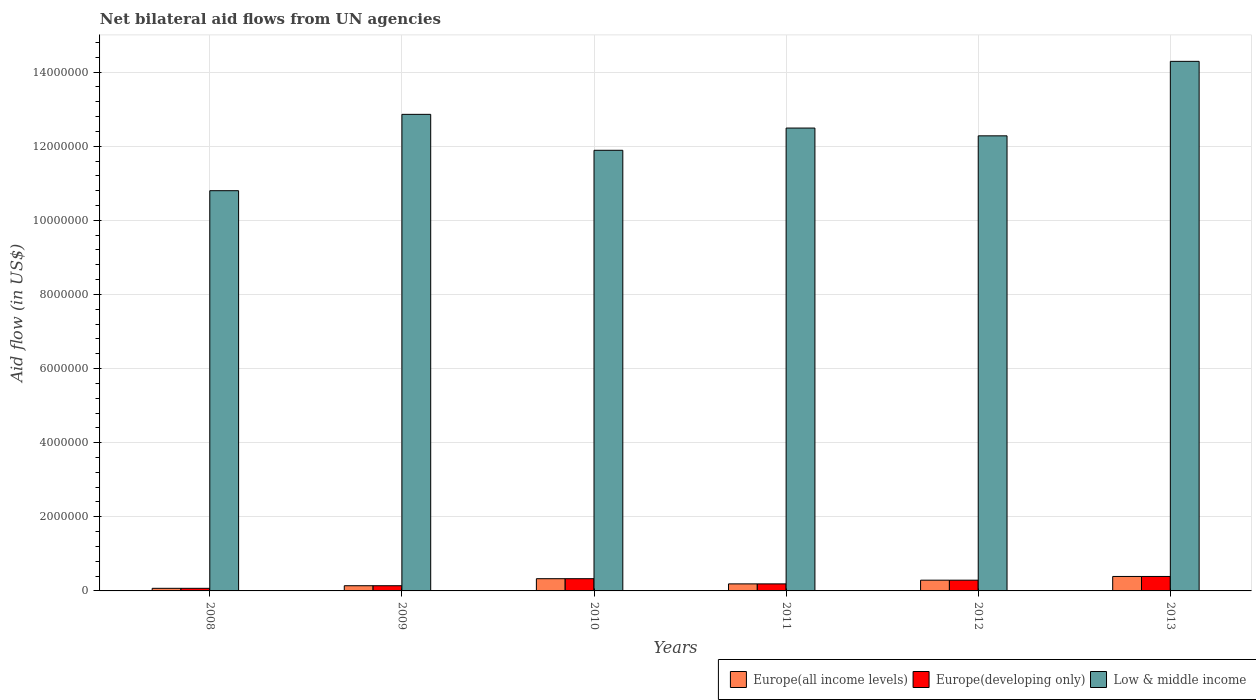How many groups of bars are there?
Make the answer very short. 6. Are the number of bars per tick equal to the number of legend labels?
Ensure brevity in your answer.  Yes. Are the number of bars on each tick of the X-axis equal?
Ensure brevity in your answer.  Yes. What is the net bilateral aid flow in Europe(developing only) in 2009?
Your response must be concise. 1.40e+05. Across all years, what is the maximum net bilateral aid flow in Low & middle income?
Your answer should be compact. 1.43e+07. Across all years, what is the minimum net bilateral aid flow in Europe(all income levels)?
Provide a succinct answer. 7.00e+04. In which year was the net bilateral aid flow in Low & middle income maximum?
Offer a very short reply. 2013. What is the total net bilateral aid flow in Low & middle income in the graph?
Ensure brevity in your answer.  7.46e+07. What is the difference between the net bilateral aid flow in Europe(all income levels) in 2010 and that in 2012?
Ensure brevity in your answer.  4.00e+04. What is the difference between the net bilateral aid flow in Low & middle income in 2010 and the net bilateral aid flow in Europe(all income levels) in 2012?
Your answer should be very brief. 1.16e+07. What is the average net bilateral aid flow in Europe(all income levels) per year?
Keep it short and to the point. 2.35e+05. In the year 2010, what is the difference between the net bilateral aid flow in Low & middle income and net bilateral aid flow in Europe(all income levels)?
Your response must be concise. 1.16e+07. What is the ratio of the net bilateral aid flow in Europe(developing only) in 2009 to that in 2013?
Provide a succinct answer. 0.36. Is the net bilateral aid flow in Europe(all income levels) in 2008 less than that in 2010?
Ensure brevity in your answer.  Yes. What is the difference between the highest and the second highest net bilateral aid flow in Europe(developing only)?
Your answer should be compact. 6.00e+04. What is the difference between the highest and the lowest net bilateral aid flow in Low & middle income?
Give a very brief answer. 3.49e+06. In how many years, is the net bilateral aid flow in Low & middle income greater than the average net bilateral aid flow in Low & middle income taken over all years?
Make the answer very short. 3. What does the 2nd bar from the left in 2011 represents?
Make the answer very short. Europe(developing only). What does the 3rd bar from the right in 2009 represents?
Provide a short and direct response. Europe(all income levels). Are all the bars in the graph horizontal?
Give a very brief answer. No. Does the graph contain any zero values?
Offer a terse response. No. Does the graph contain grids?
Give a very brief answer. Yes. How many legend labels are there?
Your answer should be very brief. 3. How are the legend labels stacked?
Offer a terse response. Horizontal. What is the title of the graph?
Make the answer very short. Net bilateral aid flows from UN agencies. Does "Togo" appear as one of the legend labels in the graph?
Provide a succinct answer. No. What is the label or title of the X-axis?
Ensure brevity in your answer.  Years. What is the label or title of the Y-axis?
Offer a very short reply. Aid flow (in US$). What is the Aid flow (in US$) of Europe(all income levels) in 2008?
Your response must be concise. 7.00e+04. What is the Aid flow (in US$) in Europe(developing only) in 2008?
Provide a succinct answer. 7.00e+04. What is the Aid flow (in US$) of Low & middle income in 2008?
Ensure brevity in your answer.  1.08e+07. What is the Aid flow (in US$) in Low & middle income in 2009?
Give a very brief answer. 1.29e+07. What is the Aid flow (in US$) in Europe(all income levels) in 2010?
Ensure brevity in your answer.  3.30e+05. What is the Aid flow (in US$) in Low & middle income in 2010?
Ensure brevity in your answer.  1.19e+07. What is the Aid flow (in US$) in Europe(all income levels) in 2011?
Your answer should be very brief. 1.90e+05. What is the Aid flow (in US$) in Europe(developing only) in 2011?
Your answer should be very brief. 1.90e+05. What is the Aid flow (in US$) of Low & middle income in 2011?
Offer a very short reply. 1.25e+07. What is the Aid flow (in US$) in Europe(developing only) in 2012?
Provide a succinct answer. 2.90e+05. What is the Aid flow (in US$) in Low & middle income in 2012?
Give a very brief answer. 1.23e+07. What is the Aid flow (in US$) in Low & middle income in 2013?
Keep it short and to the point. 1.43e+07. Across all years, what is the maximum Aid flow (in US$) in Europe(developing only)?
Ensure brevity in your answer.  3.90e+05. Across all years, what is the maximum Aid flow (in US$) of Low & middle income?
Give a very brief answer. 1.43e+07. Across all years, what is the minimum Aid flow (in US$) of Low & middle income?
Make the answer very short. 1.08e+07. What is the total Aid flow (in US$) of Europe(all income levels) in the graph?
Ensure brevity in your answer.  1.41e+06. What is the total Aid flow (in US$) of Europe(developing only) in the graph?
Your answer should be compact. 1.41e+06. What is the total Aid flow (in US$) in Low & middle income in the graph?
Make the answer very short. 7.46e+07. What is the difference between the Aid flow (in US$) of Europe(developing only) in 2008 and that in 2009?
Your answer should be compact. -7.00e+04. What is the difference between the Aid flow (in US$) of Low & middle income in 2008 and that in 2009?
Give a very brief answer. -2.06e+06. What is the difference between the Aid flow (in US$) of Low & middle income in 2008 and that in 2010?
Provide a succinct answer. -1.09e+06. What is the difference between the Aid flow (in US$) of Europe(all income levels) in 2008 and that in 2011?
Your answer should be compact. -1.20e+05. What is the difference between the Aid flow (in US$) of Low & middle income in 2008 and that in 2011?
Make the answer very short. -1.69e+06. What is the difference between the Aid flow (in US$) of Europe(all income levels) in 2008 and that in 2012?
Provide a succinct answer. -2.20e+05. What is the difference between the Aid flow (in US$) in Europe(developing only) in 2008 and that in 2012?
Keep it short and to the point. -2.20e+05. What is the difference between the Aid flow (in US$) of Low & middle income in 2008 and that in 2012?
Provide a short and direct response. -1.48e+06. What is the difference between the Aid flow (in US$) of Europe(all income levels) in 2008 and that in 2013?
Your answer should be compact. -3.20e+05. What is the difference between the Aid flow (in US$) of Europe(developing only) in 2008 and that in 2013?
Your answer should be very brief. -3.20e+05. What is the difference between the Aid flow (in US$) in Low & middle income in 2008 and that in 2013?
Offer a terse response. -3.49e+06. What is the difference between the Aid flow (in US$) of Low & middle income in 2009 and that in 2010?
Offer a very short reply. 9.70e+05. What is the difference between the Aid flow (in US$) in Europe(developing only) in 2009 and that in 2011?
Your response must be concise. -5.00e+04. What is the difference between the Aid flow (in US$) in Low & middle income in 2009 and that in 2012?
Your answer should be compact. 5.80e+05. What is the difference between the Aid flow (in US$) of Low & middle income in 2009 and that in 2013?
Provide a short and direct response. -1.43e+06. What is the difference between the Aid flow (in US$) of Europe(all income levels) in 2010 and that in 2011?
Your response must be concise. 1.40e+05. What is the difference between the Aid flow (in US$) of Europe(developing only) in 2010 and that in 2011?
Your response must be concise. 1.40e+05. What is the difference between the Aid flow (in US$) of Low & middle income in 2010 and that in 2011?
Your answer should be compact. -6.00e+05. What is the difference between the Aid flow (in US$) in Europe(all income levels) in 2010 and that in 2012?
Keep it short and to the point. 4.00e+04. What is the difference between the Aid flow (in US$) of Europe(developing only) in 2010 and that in 2012?
Your answer should be very brief. 4.00e+04. What is the difference between the Aid flow (in US$) in Low & middle income in 2010 and that in 2012?
Offer a very short reply. -3.90e+05. What is the difference between the Aid flow (in US$) of Low & middle income in 2010 and that in 2013?
Your answer should be compact. -2.40e+06. What is the difference between the Aid flow (in US$) of Low & middle income in 2011 and that in 2012?
Give a very brief answer. 2.10e+05. What is the difference between the Aid flow (in US$) of Europe(developing only) in 2011 and that in 2013?
Offer a terse response. -2.00e+05. What is the difference between the Aid flow (in US$) of Low & middle income in 2011 and that in 2013?
Provide a short and direct response. -1.80e+06. What is the difference between the Aid flow (in US$) in Low & middle income in 2012 and that in 2013?
Your response must be concise. -2.01e+06. What is the difference between the Aid flow (in US$) of Europe(all income levels) in 2008 and the Aid flow (in US$) of Low & middle income in 2009?
Make the answer very short. -1.28e+07. What is the difference between the Aid flow (in US$) of Europe(developing only) in 2008 and the Aid flow (in US$) of Low & middle income in 2009?
Offer a terse response. -1.28e+07. What is the difference between the Aid flow (in US$) of Europe(all income levels) in 2008 and the Aid flow (in US$) of Europe(developing only) in 2010?
Ensure brevity in your answer.  -2.60e+05. What is the difference between the Aid flow (in US$) of Europe(all income levels) in 2008 and the Aid flow (in US$) of Low & middle income in 2010?
Ensure brevity in your answer.  -1.18e+07. What is the difference between the Aid flow (in US$) in Europe(developing only) in 2008 and the Aid flow (in US$) in Low & middle income in 2010?
Your response must be concise. -1.18e+07. What is the difference between the Aid flow (in US$) in Europe(all income levels) in 2008 and the Aid flow (in US$) in Low & middle income in 2011?
Keep it short and to the point. -1.24e+07. What is the difference between the Aid flow (in US$) of Europe(developing only) in 2008 and the Aid flow (in US$) of Low & middle income in 2011?
Your answer should be very brief. -1.24e+07. What is the difference between the Aid flow (in US$) of Europe(all income levels) in 2008 and the Aid flow (in US$) of Low & middle income in 2012?
Offer a terse response. -1.22e+07. What is the difference between the Aid flow (in US$) of Europe(developing only) in 2008 and the Aid flow (in US$) of Low & middle income in 2012?
Provide a succinct answer. -1.22e+07. What is the difference between the Aid flow (in US$) in Europe(all income levels) in 2008 and the Aid flow (in US$) in Europe(developing only) in 2013?
Your answer should be very brief. -3.20e+05. What is the difference between the Aid flow (in US$) in Europe(all income levels) in 2008 and the Aid flow (in US$) in Low & middle income in 2013?
Ensure brevity in your answer.  -1.42e+07. What is the difference between the Aid flow (in US$) in Europe(developing only) in 2008 and the Aid flow (in US$) in Low & middle income in 2013?
Offer a very short reply. -1.42e+07. What is the difference between the Aid flow (in US$) in Europe(all income levels) in 2009 and the Aid flow (in US$) in Low & middle income in 2010?
Keep it short and to the point. -1.18e+07. What is the difference between the Aid flow (in US$) of Europe(developing only) in 2009 and the Aid flow (in US$) of Low & middle income in 2010?
Keep it short and to the point. -1.18e+07. What is the difference between the Aid flow (in US$) of Europe(all income levels) in 2009 and the Aid flow (in US$) of Low & middle income in 2011?
Keep it short and to the point. -1.24e+07. What is the difference between the Aid flow (in US$) of Europe(developing only) in 2009 and the Aid flow (in US$) of Low & middle income in 2011?
Provide a short and direct response. -1.24e+07. What is the difference between the Aid flow (in US$) in Europe(all income levels) in 2009 and the Aid flow (in US$) in Low & middle income in 2012?
Ensure brevity in your answer.  -1.21e+07. What is the difference between the Aid flow (in US$) in Europe(developing only) in 2009 and the Aid flow (in US$) in Low & middle income in 2012?
Your answer should be very brief. -1.21e+07. What is the difference between the Aid flow (in US$) of Europe(all income levels) in 2009 and the Aid flow (in US$) of Low & middle income in 2013?
Offer a terse response. -1.42e+07. What is the difference between the Aid flow (in US$) of Europe(developing only) in 2009 and the Aid flow (in US$) of Low & middle income in 2013?
Give a very brief answer. -1.42e+07. What is the difference between the Aid flow (in US$) in Europe(all income levels) in 2010 and the Aid flow (in US$) in Europe(developing only) in 2011?
Your answer should be compact. 1.40e+05. What is the difference between the Aid flow (in US$) in Europe(all income levels) in 2010 and the Aid flow (in US$) in Low & middle income in 2011?
Provide a short and direct response. -1.22e+07. What is the difference between the Aid flow (in US$) in Europe(developing only) in 2010 and the Aid flow (in US$) in Low & middle income in 2011?
Your answer should be compact. -1.22e+07. What is the difference between the Aid flow (in US$) in Europe(all income levels) in 2010 and the Aid flow (in US$) in Low & middle income in 2012?
Keep it short and to the point. -1.20e+07. What is the difference between the Aid flow (in US$) of Europe(developing only) in 2010 and the Aid flow (in US$) of Low & middle income in 2012?
Provide a succinct answer. -1.20e+07. What is the difference between the Aid flow (in US$) of Europe(all income levels) in 2010 and the Aid flow (in US$) of Europe(developing only) in 2013?
Offer a terse response. -6.00e+04. What is the difference between the Aid flow (in US$) in Europe(all income levels) in 2010 and the Aid flow (in US$) in Low & middle income in 2013?
Ensure brevity in your answer.  -1.40e+07. What is the difference between the Aid flow (in US$) in Europe(developing only) in 2010 and the Aid flow (in US$) in Low & middle income in 2013?
Make the answer very short. -1.40e+07. What is the difference between the Aid flow (in US$) in Europe(all income levels) in 2011 and the Aid flow (in US$) in Europe(developing only) in 2012?
Offer a terse response. -1.00e+05. What is the difference between the Aid flow (in US$) of Europe(all income levels) in 2011 and the Aid flow (in US$) of Low & middle income in 2012?
Provide a short and direct response. -1.21e+07. What is the difference between the Aid flow (in US$) of Europe(developing only) in 2011 and the Aid flow (in US$) of Low & middle income in 2012?
Offer a very short reply. -1.21e+07. What is the difference between the Aid flow (in US$) of Europe(all income levels) in 2011 and the Aid flow (in US$) of Low & middle income in 2013?
Your answer should be compact. -1.41e+07. What is the difference between the Aid flow (in US$) in Europe(developing only) in 2011 and the Aid flow (in US$) in Low & middle income in 2013?
Provide a succinct answer. -1.41e+07. What is the difference between the Aid flow (in US$) of Europe(all income levels) in 2012 and the Aid flow (in US$) of Low & middle income in 2013?
Provide a short and direct response. -1.40e+07. What is the difference between the Aid flow (in US$) of Europe(developing only) in 2012 and the Aid flow (in US$) of Low & middle income in 2013?
Offer a very short reply. -1.40e+07. What is the average Aid flow (in US$) in Europe(all income levels) per year?
Make the answer very short. 2.35e+05. What is the average Aid flow (in US$) of Europe(developing only) per year?
Make the answer very short. 2.35e+05. What is the average Aid flow (in US$) in Low & middle income per year?
Provide a succinct answer. 1.24e+07. In the year 2008, what is the difference between the Aid flow (in US$) of Europe(all income levels) and Aid flow (in US$) of Europe(developing only)?
Give a very brief answer. 0. In the year 2008, what is the difference between the Aid flow (in US$) of Europe(all income levels) and Aid flow (in US$) of Low & middle income?
Offer a very short reply. -1.07e+07. In the year 2008, what is the difference between the Aid flow (in US$) in Europe(developing only) and Aid flow (in US$) in Low & middle income?
Your answer should be very brief. -1.07e+07. In the year 2009, what is the difference between the Aid flow (in US$) of Europe(all income levels) and Aid flow (in US$) of Europe(developing only)?
Your answer should be very brief. 0. In the year 2009, what is the difference between the Aid flow (in US$) of Europe(all income levels) and Aid flow (in US$) of Low & middle income?
Your answer should be very brief. -1.27e+07. In the year 2009, what is the difference between the Aid flow (in US$) of Europe(developing only) and Aid flow (in US$) of Low & middle income?
Provide a short and direct response. -1.27e+07. In the year 2010, what is the difference between the Aid flow (in US$) of Europe(all income levels) and Aid flow (in US$) of Europe(developing only)?
Your answer should be compact. 0. In the year 2010, what is the difference between the Aid flow (in US$) of Europe(all income levels) and Aid flow (in US$) of Low & middle income?
Ensure brevity in your answer.  -1.16e+07. In the year 2010, what is the difference between the Aid flow (in US$) of Europe(developing only) and Aid flow (in US$) of Low & middle income?
Your response must be concise. -1.16e+07. In the year 2011, what is the difference between the Aid flow (in US$) in Europe(all income levels) and Aid flow (in US$) in Low & middle income?
Provide a short and direct response. -1.23e+07. In the year 2011, what is the difference between the Aid flow (in US$) of Europe(developing only) and Aid flow (in US$) of Low & middle income?
Give a very brief answer. -1.23e+07. In the year 2012, what is the difference between the Aid flow (in US$) of Europe(all income levels) and Aid flow (in US$) of Europe(developing only)?
Make the answer very short. 0. In the year 2012, what is the difference between the Aid flow (in US$) of Europe(all income levels) and Aid flow (in US$) of Low & middle income?
Give a very brief answer. -1.20e+07. In the year 2012, what is the difference between the Aid flow (in US$) in Europe(developing only) and Aid flow (in US$) in Low & middle income?
Offer a very short reply. -1.20e+07. In the year 2013, what is the difference between the Aid flow (in US$) of Europe(all income levels) and Aid flow (in US$) of Low & middle income?
Offer a very short reply. -1.39e+07. In the year 2013, what is the difference between the Aid flow (in US$) of Europe(developing only) and Aid flow (in US$) of Low & middle income?
Provide a short and direct response. -1.39e+07. What is the ratio of the Aid flow (in US$) in Europe(developing only) in 2008 to that in 2009?
Your answer should be compact. 0.5. What is the ratio of the Aid flow (in US$) in Low & middle income in 2008 to that in 2009?
Provide a succinct answer. 0.84. What is the ratio of the Aid flow (in US$) of Europe(all income levels) in 2008 to that in 2010?
Ensure brevity in your answer.  0.21. What is the ratio of the Aid flow (in US$) of Europe(developing only) in 2008 to that in 2010?
Keep it short and to the point. 0.21. What is the ratio of the Aid flow (in US$) in Low & middle income in 2008 to that in 2010?
Offer a terse response. 0.91. What is the ratio of the Aid flow (in US$) of Europe(all income levels) in 2008 to that in 2011?
Keep it short and to the point. 0.37. What is the ratio of the Aid flow (in US$) in Europe(developing only) in 2008 to that in 2011?
Ensure brevity in your answer.  0.37. What is the ratio of the Aid flow (in US$) of Low & middle income in 2008 to that in 2011?
Ensure brevity in your answer.  0.86. What is the ratio of the Aid flow (in US$) of Europe(all income levels) in 2008 to that in 2012?
Your answer should be very brief. 0.24. What is the ratio of the Aid flow (in US$) of Europe(developing only) in 2008 to that in 2012?
Offer a very short reply. 0.24. What is the ratio of the Aid flow (in US$) of Low & middle income in 2008 to that in 2012?
Ensure brevity in your answer.  0.88. What is the ratio of the Aid flow (in US$) of Europe(all income levels) in 2008 to that in 2013?
Provide a short and direct response. 0.18. What is the ratio of the Aid flow (in US$) in Europe(developing only) in 2008 to that in 2013?
Keep it short and to the point. 0.18. What is the ratio of the Aid flow (in US$) in Low & middle income in 2008 to that in 2013?
Give a very brief answer. 0.76. What is the ratio of the Aid flow (in US$) in Europe(all income levels) in 2009 to that in 2010?
Ensure brevity in your answer.  0.42. What is the ratio of the Aid flow (in US$) of Europe(developing only) in 2009 to that in 2010?
Provide a succinct answer. 0.42. What is the ratio of the Aid flow (in US$) in Low & middle income in 2009 to that in 2010?
Provide a short and direct response. 1.08. What is the ratio of the Aid flow (in US$) of Europe(all income levels) in 2009 to that in 2011?
Ensure brevity in your answer.  0.74. What is the ratio of the Aid flow (in US$) in Europe(developing only) in 2009 to that in 2011?
Give a very brief answer. 0.74. What is the ratio of the Aid flow (in US$) in Low & middle income in 2009 to that in 2011?
Your answer should be very brief. 1.03. What is the ratio of the Aid flow (in US$) in Europe(all income levels) in 2009 to that in 2012?
Your response must be concise. 0.48. What is the ratio of the Aid flow (in US$) of Europe(developing only) in 2009 to that in 2012?
Provide a succinct answer. 0.48. What is the ratio of the Aid flow (in US$) in Low & middle income in 2009 to that in 2012?
Make the answer very short. 1.05. What is the ratio of the Aid flow (in US$) of Europe(all income levels) in 2009 to that in 2013?
Give a very brief answer. 0.36. What is the ratio of the Aid flow (in US$) of Europe(developing only) in 2009 to that in 2013?
Provide a succinct answer. 0.36. What is the ratio of the Aid flow (in US$) in Low & middle income in 2009 to that in 2013?
Your response must be concise. 0.9. What is the ratio of the Aid flow (in US$) of Europe(all income levels) in 2010 to that in 2011?
Keep it short and to the point. 1.74. What is the ratio of the Aid flow (in US$) of Europe(developing only) in 2010 to that in 2011?
Your answer should be compact. 1.74. What is the ratio of the Aid flow (in US$) of Europe(all income levels) in 2010 to that in 2012?
Your answer should be compact. 1.14. What is the ratio of the Aid flow (in US$) in Europe(developing only) in 2010 to that in 2012?
Your response must be concise. 1.14. What is the ratio of the Aid flow (in US$) in Low & middle income in 2010 to that in 2012?
Provide a short and direct response. 0.97. What is the ratio of the Aid flow (in US$) in Europe(all income levels) in 2010 to that in 2013?
Give a very brief answer. 0.85. What is the ratio of the Aid flow (in US$) of Europe(developing only) in 2010 to that in 2013?
Your response must be concise. 0.85. What is the ratio of the Aid flow (in US$) of Low & middle income in 2010 to that in 2013?
Give a very brief answer. 0.83. What is the ratio of the Aid flow (in US$) in Europe(all income levels) in 2011 to that in 2012?
Provide a short and direct response. 0.66. What is the ratio of the Aid flow (in US$) of Europe(developing only) in 2011 to that in 2012?
Make the answer very short. 0.66. What is the ratio of the Aid flow (in US$) of Low & middle income in 2011 to that in 2012?
Provide a short and direct response. 1.02. What is the ratio of the Aid flow (in US$) in Europe(all income levels) in 2011 to that in 2013?
Make the answer very short. 0.49. What is the ratio of the Aid flow (in US$) in Europe(developing only) in 2011 to that in 2013?
Offer a very short reply. 0.49. What is the ratio of the Aid flow (in US$) of Low & middle income in 2011 to that in 2013?
Offer a terse response. 0.87. What is the ratio of the Aid flow (in US$) in Europe(all income levels) in 2012 to that in 2013?
Provide a succinct answer. 0.74. What is the ratio of the Aid flow (in US$) of Europe(developing only) in 2012 to that in 2013?
Make the answer very short. 0.74. What is the ratio of the Aid flow (in US$) in Low & middle income in 2012 to that in 2013?
Your answer should be very brief. 0.86. What is the difference between the highest and the second highest Aid flow (in US$) of Europe(developing only)?
Your answer should be very brief. 6.00e+04. What is the difference between the highest and the second highest Aid flow (in US$) of Low & middle income?
Keep it short and to the point. 1.43e+06. What is the difference between the highest and the lowest Aid flow (in US$) in Europe(developing only)?
Offer a very short reply. 3.20e+05. What is the difference between the highest and the lowest Aid flow (in US$) in Low & middle income?
Keep it short and to the point. 3.49e+06. 